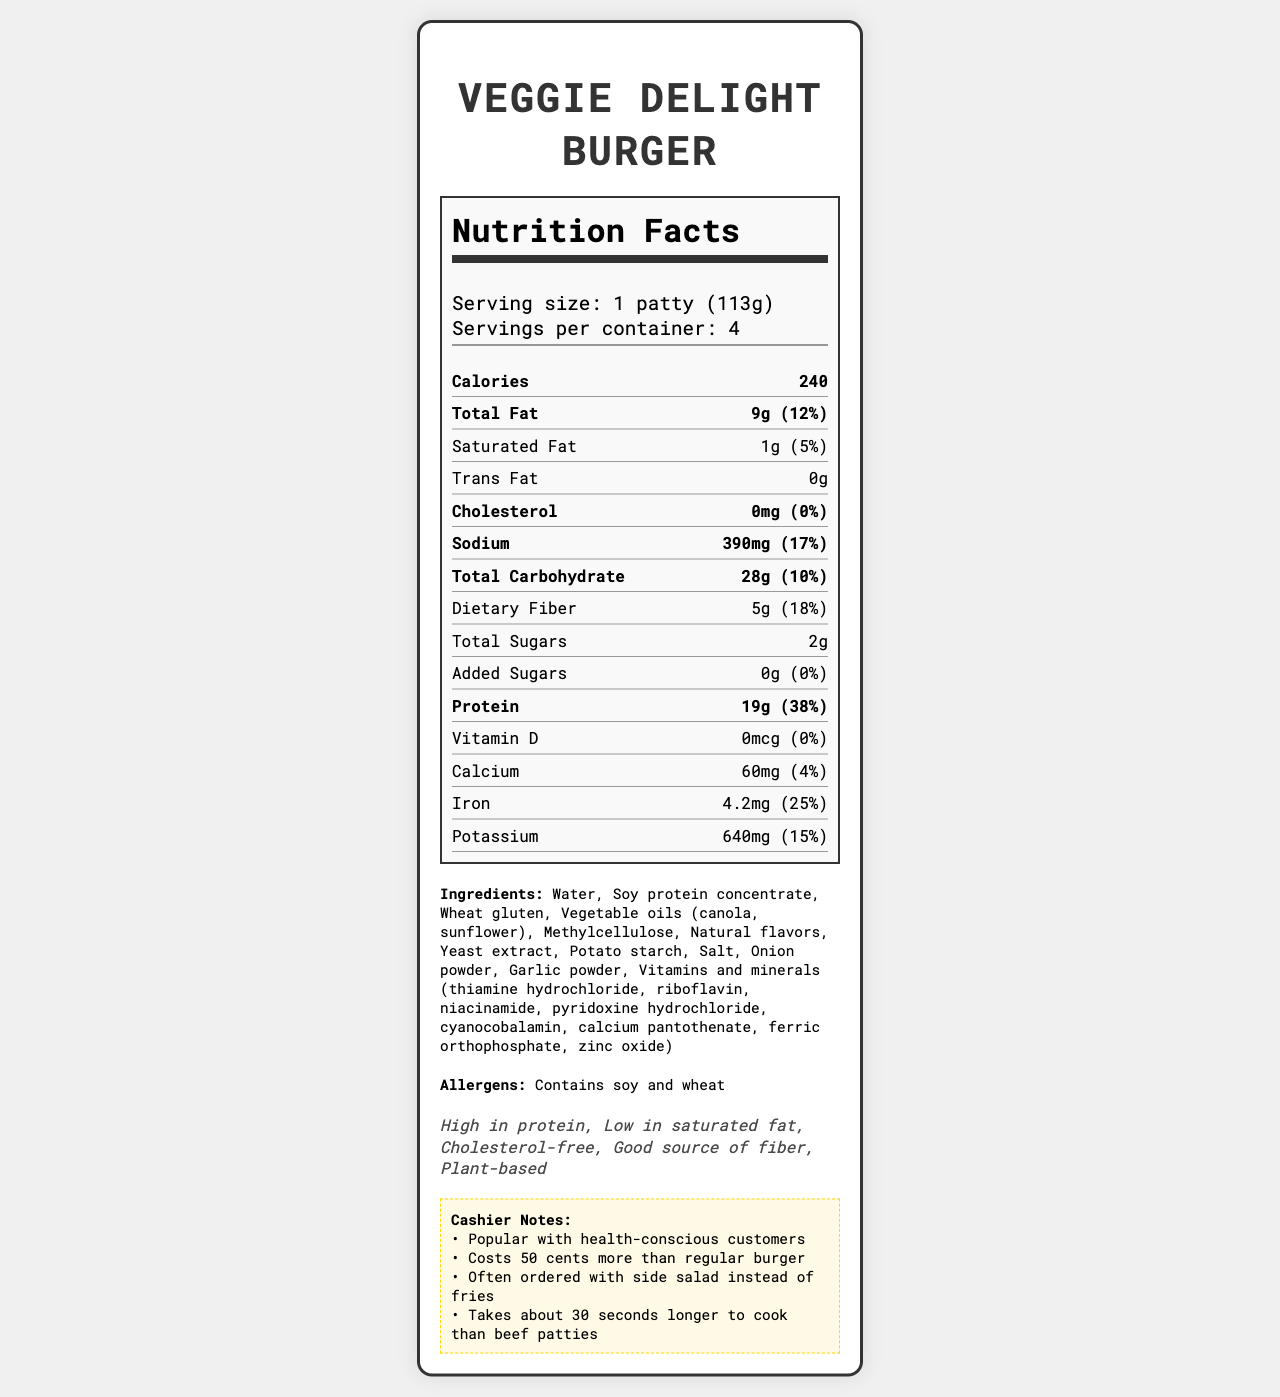what is the serving size of the Veggie Delight Burger? The serving size is clearly indicated in the document as "1 patty (113g)".
Answer: 1 patty (113g) how many calories are there per serving? The document states that each serving has 240 calories under the "Nutrition Facts" section.
Answer: 240 what is the protein content per serving? The protein content per serving is listed as 19g in the "Nutrition Facts" section.
Answer: 19g how many grams of total fat does the Veggie Delight Burger contain? The total fat content is indicated as 9g under the "Nutrition Facts" section.
Answer: 9g how much saturated fat is in each serving and its daily value? The saturated fat content per serving is 1g, which is 5% of the daily value, as specified in the nutrition label.
Answer: 1g (5%) does the Veggie Delight Burger contain any trans fat? The document states that the trans fat content is 0g under the "Nutrition Facts" section.
Answer: No is this product cholesterol-free? The document shows that the cholesterol content is 0mg, meaning it's cholesterol-free.
Answer: Yes how much dietary fiber is in a serving? The dietary fiber content per serving is listed as 5g under the "Nutrition Facts" section.
Answer: 5g how many servings are there per container? The document specifies that there are 4 servings per container in the "Serving Info" section.
Answer: 4 what allergens are present in this product? The document lists "Contains soy and wheat" under the "Allergens" section.
Answer: Soy and wheat what are the main ingredients of the Veggie Delight Burger? The primary ingredients listed are water, soy protein concentrate, wheat gluten, and vegetable oils (canola, sunflower).
Answer: Water, Soy protein concentrate, Wheat gluten, Vegetable oils (canola, sunflower) what is the sodium content per serving? The sodium content is 390mg per serving, as indicated under the "Nutrition Facts" section.
Answer: 390mg how much iron does this burger provide in terms of daily value percentage? The iron content is listed as providing 25% of the Daily Value in the document.
Answer: 25% how much added sugar is there in each serving? A. 2g B. 1g C. 0g The document specifies that there are 0g of added sugars per serving.
Answer: C what's the daily value percentage of calcium provided by a Veggie Delight Burger? A. 25% B. 4% C. 38% The daily value percentage of calcium is 4%, as listed in the "Nutrition Facts" section.
Answer: B what is the iron content per serving? A. 2.5mg B. 4.2mg C. 1.0mg The iron content per serving is 4.2mg, according to the nutrition label.
Answer: B cannot heme iron in this product? The document does not specify the type of iron, only the amount, so we cannot determine this from the provided information.
Answer: Cannot be determined is this product considered high in protein? The document states "High in protein" under the "Marketing Claims" section.
Answer: Yes what are the marketing claims made about this product? The marketing claims are listed as "High in protein, Low in saturated fat, Cholesterol-free, Good source of fiber, Plant-based".
Answer: High in protein, Low in saturated fat, Cholesterol-free, Good source of fiber, Plant-based how much potassium is in each serving? The potassium content per serving is listed as 640mg in the "Nutrition Facts" section.
Answer: 640mg does this burger contain any vitamin D? The document shows that the vitamin D content is 0mcg, so it does not contain any vitamin D.
Answer: No what makes this product popular among health-conscious customers? The document's marketing claims highlight features that appeal to health-conscious customers, such as high protein content, low saturated fat, being cholesterol-free, a good source of fiber, and being plant-based.
Answer: High protein content, low in saturated fat, cholesterol-free, good source of fiber, plant-based how would you describe the entire document? The document is a comprehensive overview of the Veggie Delight Burger's nutritional profile, ingredient list, allergens, marketing claims, and additional information such as cashier notes. It is designed to inform both customers and staff about the product's health benefits and preparation details.
Answer: The document provides detailed nutritional information about the Veggie Delight Burger, including serving sizes, calorie count, fat, cholesterol, sodium, carbohydrates, fiber, sugars, protein, vitamins, and minerals. It also lists ingredients, allergens, and marketing claims, along with some notes for cashiers. 